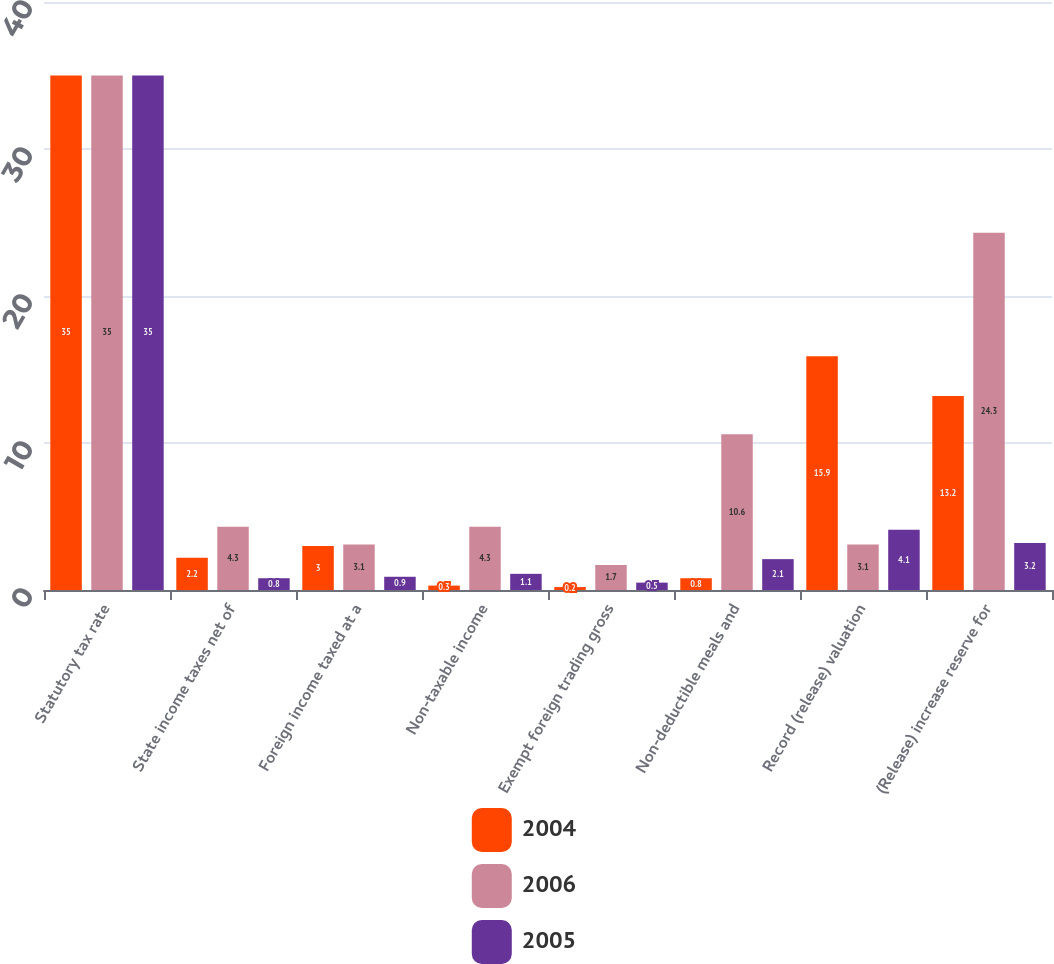Convert chart. <chart><loc_0><loc_0><loc_500><loc_500><stacked_bar_chart><ecel><fcel>Statutory tax rate<fcel>State income taxes net of<fcel>Foreign income taxed at a<fcel>Non-taxable income<fcel>Exempt foreign trading gross<fcel>Non-deductible meals and<fcel>Record (release) valuation<fcel>(Release) increase reserve for<nl><fcel>2004<fcel>35<fcel>2.2<fcel>3<fcel>0.3<fcel>0.2<fcel>0.8<fcel>15.9<fcel>13.2<nl><fcel>2006<fcel>35<fcel>4.3<fcel>3.1<fcel>4.3<fcel>1.7<fcel>10.6<fcel>3.1<fcel>24.3<nl><fcel>2005<fcel>35<fcel>0.8<fcel>0.9<fcel>1.1<fcel>0.5<fcel>2.1<fcel>4.1<fcel>3.2<nl></chart> 